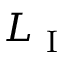Convert formula to latex. <formula><loc_0><loc_0><loc_500><loc_500>L _ { I }</formula> 